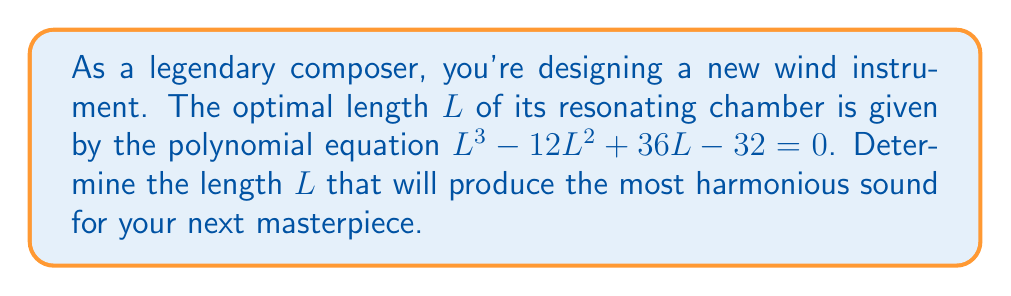Could you help me with this problem? To solve this polynomial equation, we'll use the following steps:

1) First, we recognize this as a cubic equation in the form $ax^3 + bx^2 + cx + d = 0$, where:
   $a = 1$, $b = -12$, $c = 36$, and $d = -32$

2) We can use the rational root theorem to find potential rational solutions. The possible rational roots are the factors of the constant term (32): ±1, ±2, ±4, ±8, ±16, ±32

3) Let's test these values in the equation:

   For $L = 4$:
   $4^3 - 12(4^2) + 36(4) - 32 = 64 - 192 + 144 - 32 = -16 \neq 0$

   For $L = 2$:
   $2^3 - 12(2^2) + 36(2) - 32 = 8 - 48 + 72 - 32 = 0$

4) We've found a solution: $L = 2$. This means $(L - 2)$ is a factor of the polynomial.

5) We can factor out $(L - 2)$:
   $L^3 - 12L^2 + 36L - 32 = (L - 2)(L^2 - 10L + 16)$

6) The quadratic factor $L^2 - 10L + 16$ can be solved using the quadratic formula:
   $L = \frac{-b \pm \sqrt{b^2 - 4ac}}{2a} = \frac{10 \pm \sqrt{100 - 64}}{2} = \frac{10 \pm 6}{2}$

7) This gives us two more solutions: $L = 8$ or $L = 2$

Therefore, the three solutions are $L = 2$ (twice) and $L = 8$. Since we're looking for the optimal length, and 2 is the repeated root, this is likely the optimal solution for the most harmonious sound.
Answer: $L = 2$ 